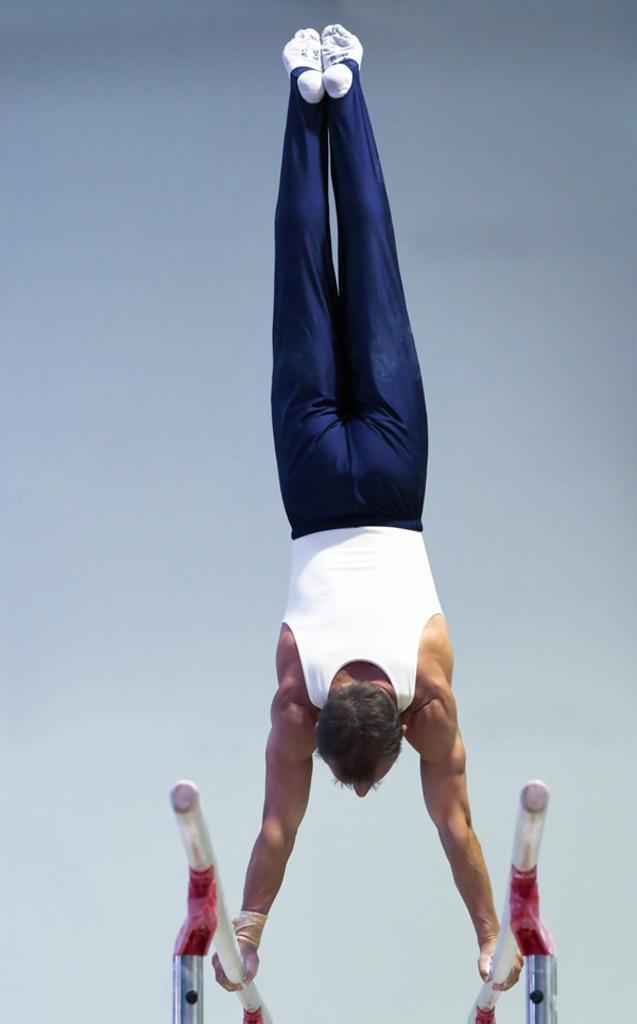How would you summarize this image in a sentence or two? In the image we can see there is a person doing gymnastics. He is standing upside down and he is holding iron rods. 